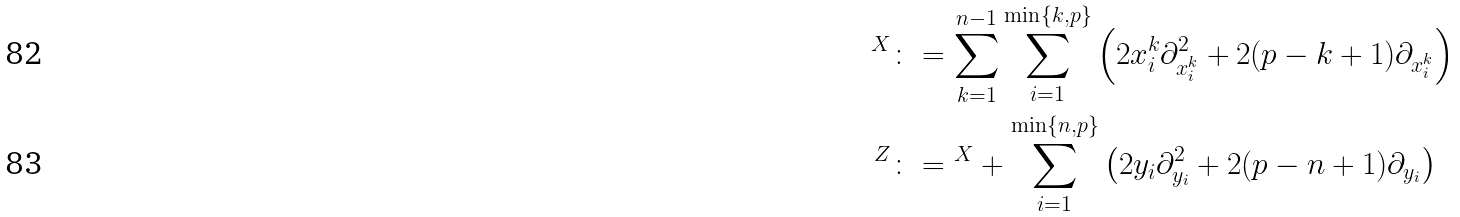Convert formula to latex. <formula><loc_0><loc_0><loc_500><loc_500>\AA ^ { X } & \colon = \sum _ { k = 1 } ^ { n - 1 } \sum _ { i = 1 } ^ { \min \{ k , p \} } \left ( 2 x ^ { k } _ { i } \partial ^ { 2 } _ { x ^ { k } _ { i } } + 2 ( p - k + 1 ) \partial _ { x ^ { k } _ { i } } \right ) \\ \AA ^ { Z } & \colon = \AA ^ { X } + \sum _ { i = 1 } ^ { \min \{ n , p \} } \left ( 2 y _ { i } \partial _ { y _ { i } } ^ { 2 } + 2 ( p - n + 1 ) \partial _ { y _ { i } } \right )</formula> 